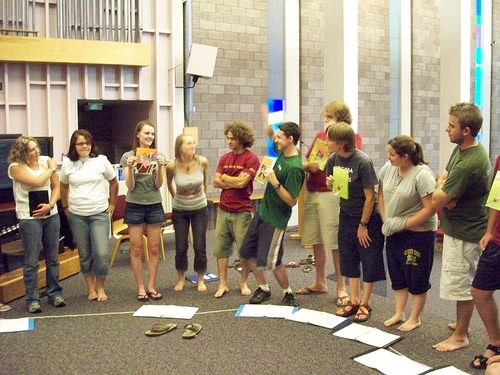<image>
Is there a building behind the woman? Yes. From this viewpoint, the building is positioned behind the woman, with the woman partially or fully occluding the building. 